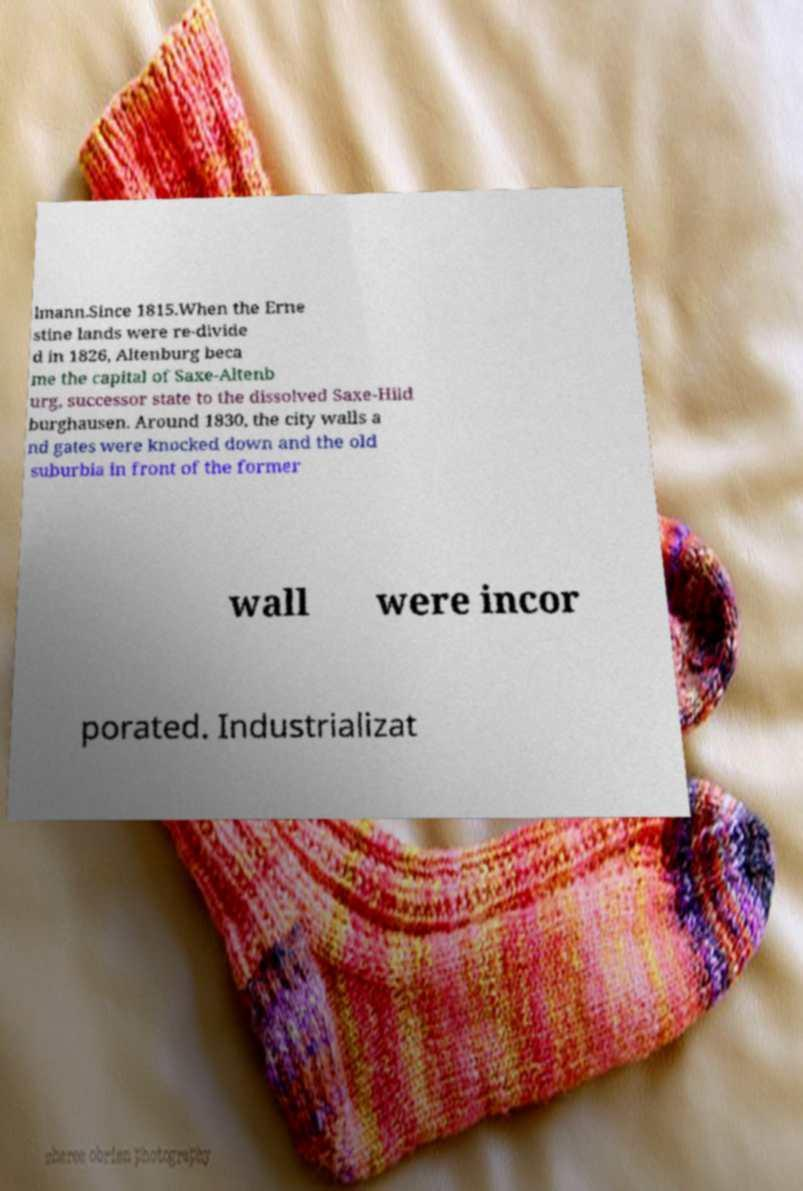Please identify and transcribe the text found in this image. lmann.Since 1815.When the Erne stine lands were re-divide d in 1826, Altenburg beca me the capital of Saxe-Altenb urg, successor state to the dissolved Saxe-Hild burghausen. Around 1830, the city walls a nd gates were knocked down and the old suburbia in front of the former wall were incor porated. Industrializat 